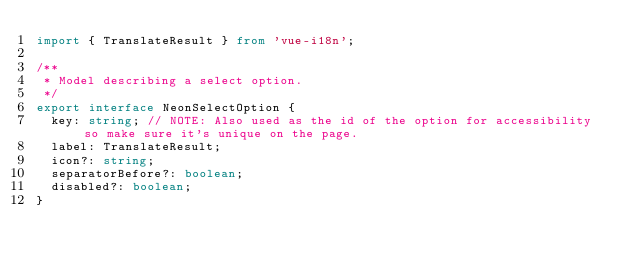Convert code to text. <code><loc_0><loc_0><loc_500><loc_500><_TypeScript_>import { TranslateResult } from 'vue-i18n';

/**
 * Model describing a select option.
 */
export interface NeonSelectOption {
  key: string; // NOTE: Also used as the id of the option for accessibility so make sure it's unique on the page.
  label: TranslateResult;
  icon?: string;
  separatorBefore?: boolean;
  disabled?: boolean;
}
</code> 